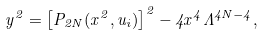Convert formula to latex. <formula><loc_0><loc_0><loc_500><loc_500>y ^ { 2 } = \left [ P _ { 2 N } ( x ^ { 2 } , u _ { i } ) \right ] ^ { 2 } - 4 x ^ { 4 } \Lambda ^ { 4 N - 4 } ,</formula> 